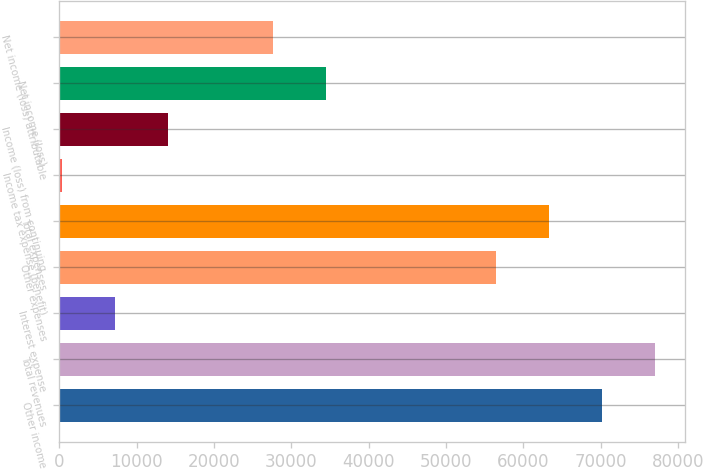Convert chart. <chart><loc_0><loc_0><loc_500><loc_500><bar_chart><fcel>Other income<fcel>Total revenues<fcel>Interest expense<fcel>Other expenses<fcel>Total expenses<fcel>Income tax expense (benefit)<fcel>Income (loss) from continuing<fcel>Net income (loss)<fcel>Net income (loss) attributable<nl><fcel>70180.6<fcel>77012.4<fcel>7191.8<fcel>56517<fcel>63348.8<fcel>360<fcel>14023.6<fcel>34519<fcel>27687.2<nl></chart> 